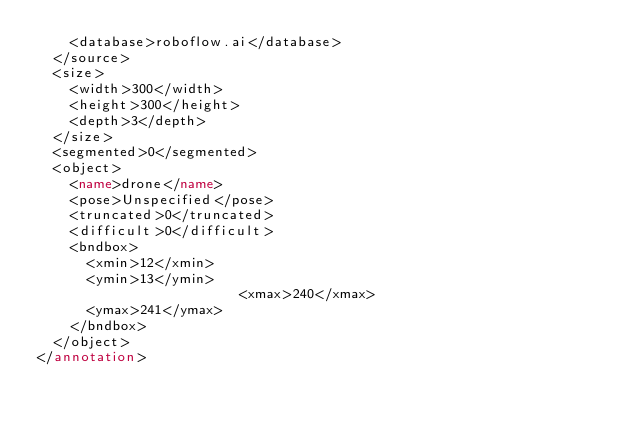Convert code to text. <code><loc_0><loc_0><loc_500><loc_500><_XML_>		<database>roboflow.ai</database>
	</source>
	<size>
		<width>300</width>
		<height>300</height>
		<depth>3</depth>
	</size>
	<segmented>0</segmented>
	<object>
		<name>drone</name>
		<pose>Unspecified</pose>
		<truncated>0</truncated>
		<difficult>0</difficult>
		<bndbox>
			<xmin>12</xmin>
			<ymin>13</ymin>
                        <xmax>240</xmax>
			<ymax>241</ymax>
		</bndbox>
	</object>
</annotation>
</code> 